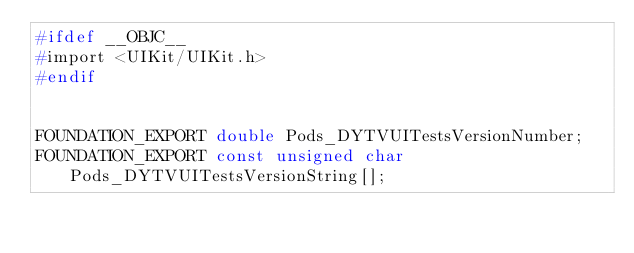Convert code to text. <code><loc_0><loc_0><loc_500><loc_500><_C_>#ifdef __OBJC__
#import <UIKit/UIKit.h>
#endif


FOUNDATION_EXPORT double Pods_DYTVUITestsVersionNumber;
FOUNDATION_EXPORT const unsigned char Pods_DYTVUITestsVersionString[];

</code> 